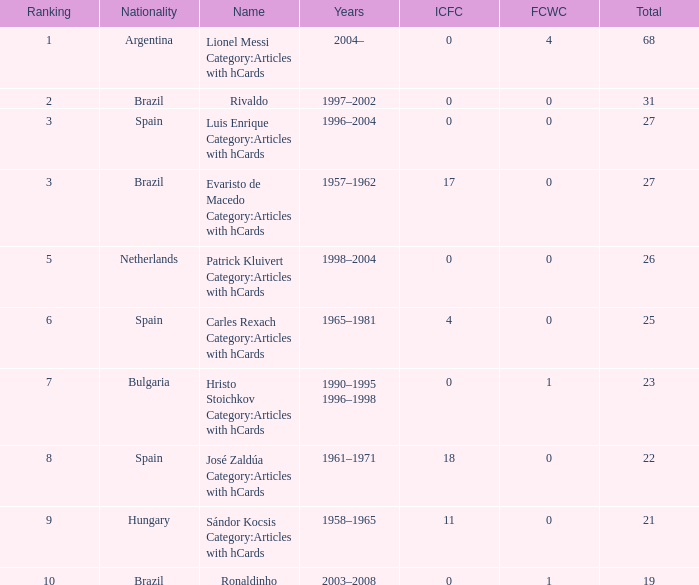What is the lowest ranking associated with a total of 23? 7.0. 